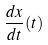<formula> <loc_0><loc_0><loc_500><loc_500>\frac { d x } { d t } ( t )</formula> 